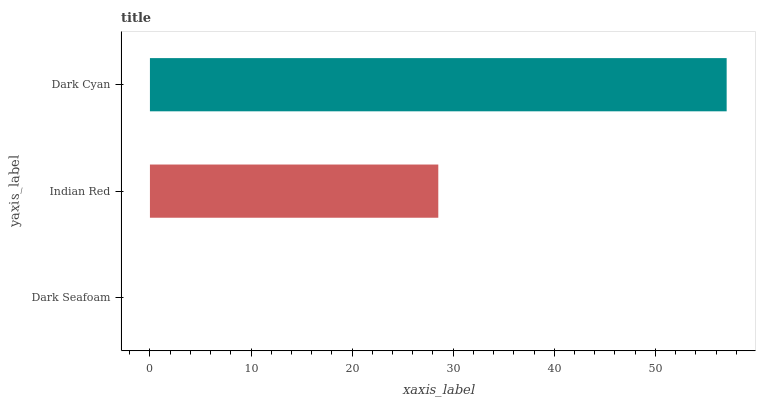Is Dark Seafoam the minimum?
Answer yes or no. Yes. Is Dark Cyan the maximum?
Answer yes or no. Yes. Is Indian Red the minimum?
Answer yes or no. No. Is Indian Red the maximum?
Answer yes or no. No. Is Indian Red greater than Dark Seafoam?
Answer yes or no. Yes. Is Dark Seafoam less than Indian Red?
Answer yes or no. Yes. Is Dark Seafoam greater than Indian Red?
Answer yes or no. No. Is Indian Red less than Dark Seafoam?
Answer yes or no. No. Is Indian Red the high median?
Answer yes or no. Yes. Is Indian Red the low median?
Answer yes or no. Yes. Is Dark Seafoam the high median?
Answer yes or no. No. Is Dark Seafoam the low median?
Answer yes or no. No. 